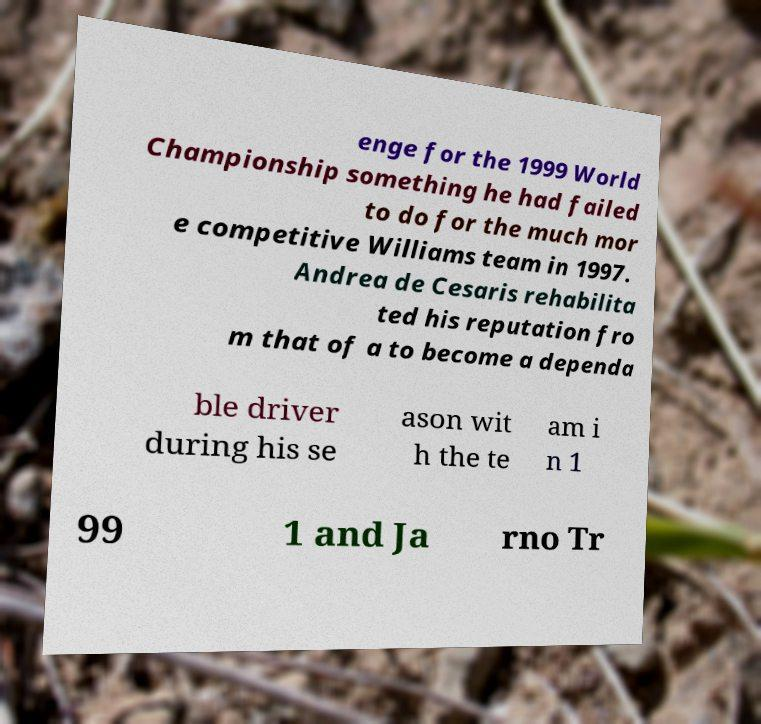What messages or text are displayed in this image? I need them in a readable, typed format. enge for the 1999 World Championship something he had failed to do for the much mor e competitive Williams team in 1997. Andrea de Cesaris rehabilita ted his reputation fro m that of a to become a dependa ble driver during his se ason wit h the te am i n 1 99 1 and Ja rno Tr 